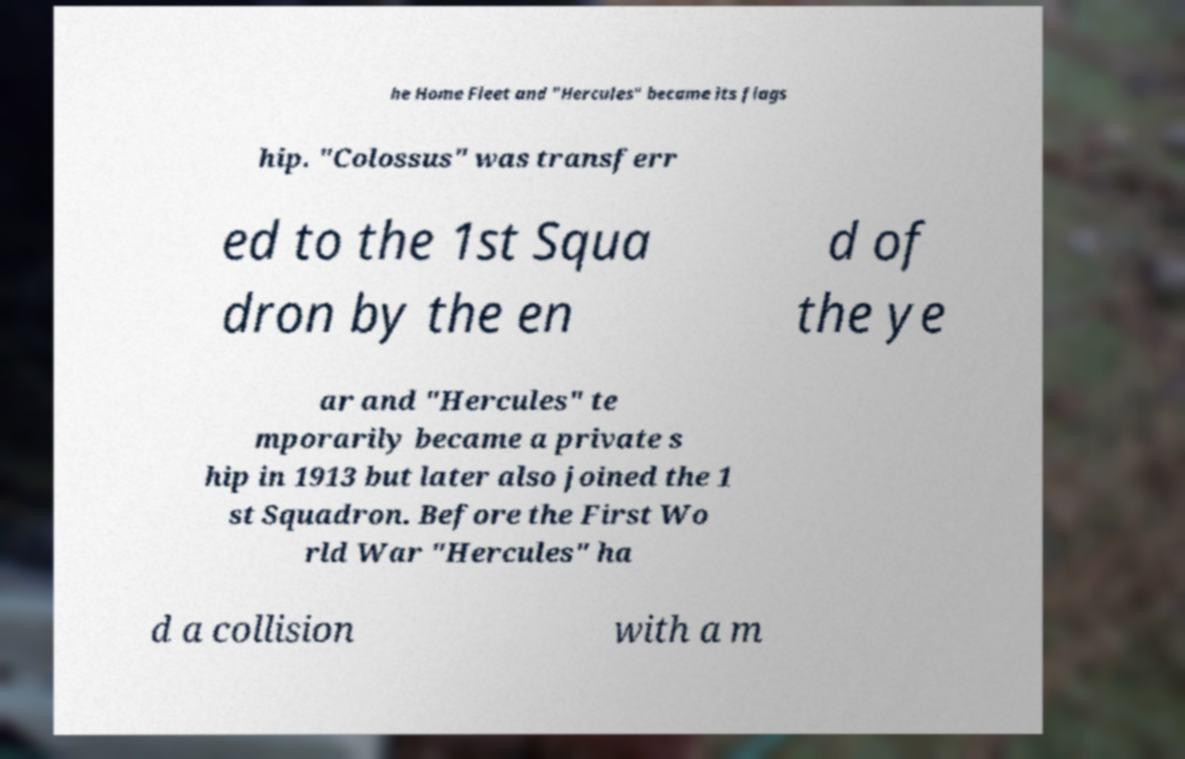Could you extract and type out the text from this image? he Home Fleet and "Hercules" became its flags hip. "Colossus" was transferr ed to the 1st Squa dron by the en d of the ye ar and "Hercules" te mporarily became a private s hip in 1913 but later also joined the 1 st Squadron. Before the First Wo rld War "Hercules" ha d a collision with a m 